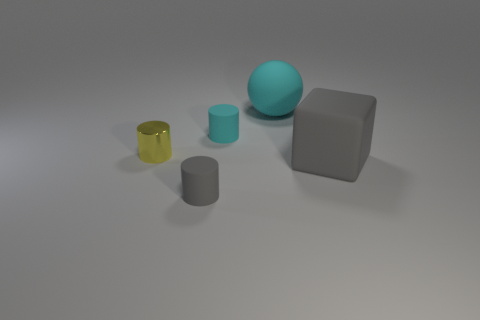Subtract all rubber cylinders. How many cylinders are left? 1 Subtract all cyan cubes. Subtract all red cylinders. How many cubes are left? 1 Subtract all yellow cubes. How many yellow balls are left? 0 Subtract all matte cylinders. Subtract all large green shiny things. How many objects are left? 3 Add 4 big gray cubes. How many big gray cubes are left? 5 Add 4 big cyan objects. How many big cyan objects exist? 5 Add 5 small cyan cylinders. How many objects exist? 10 Subtract 1 cyan balls. How many objects are left? 4 Subtract all balls. How many objects are left? 4 